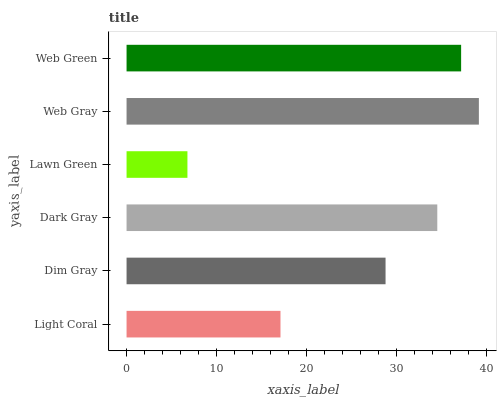Is Lawn Green the minimum?
Answer yes or no. Yes. Is Web Gray the maximum?
Answer yes or no. Yes. Is Dim Gray the minimum?
Answer yes or no. No. Is Dim Gray the maximum?
Answer yes or no. No. Is Dim Gray greater than Light Coral?
Answer yes or no. Yes. Is Light Coral less than Dim Gray?
Answer yes or no. Yes. Is Light Coral greater than Dim Gray?
Answer yes or no. No. Is Dim Gray less than Light Coral?
Answer yes or no. No. Is Dark Gray the high median?
Answer yes or no. Yes. Is Dim Gray the low median?
Answer yes or no. Yes. Is Web Gray the high median?
Answer yes or no. No. Is Web Gray the low median?
Answer yes or no. No. 